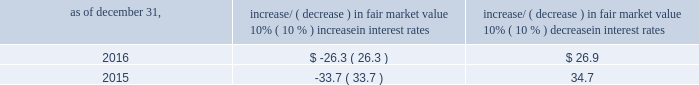Item 7a .
Quantitative and qualitative disclosures about market risk ( amounts in millions ) in the normal course of business , we are exposed to market risks related to interest rates , foreign currency rates and certain balance sheet items .
From time to time , we use derivative instruments , pursuant to established guidelines and policies , to manage some portion of these risks .
Derivative instruments utilized in our hedging activities are viewed as risk management tools and are not used for trading or speculative purposes .
Interest rates our exposure to market risk for changes in interest rates relates primarily to the fair market value and cash flows of our debt obligations .
The majority of our debt ( approximately 93% ( 93 % ) and 89% ( 89 % ) as of december 31 , 2016 and 2015 , respectively ) bears interest at fixed rates .
We do have debt with variable interest rates , but a 10% ( 10 % ) increase or decrease in interest rates would not be material to our interest expense or cash flows .
The fair market value of our debt is sensitive to changes in interest rates , and the impact of a 10% ( 10 % ) change in interest rates is summarized below .
Increase/ ( decrease ) in fair market value as of december 31 , 10% ( 10 % ) increase in interest rates 10% ( 10 % ) decrease in interest rates .
We have used interest rate swaps for risk management purposes to manage our exposure to changes in interest rates .
We do not have any interest rate swaps outstanding as of december 31 , 2016 .
We had $ 1100.6 of cash , cash equivalents and marketable securities as of december 31 , 2016 that we generally invest in conservative , short-term bank deposits or securities .
The interest income generated from these investments is subject to both domestic and foreign interest rate movements .
During 2016 and 2015 , we had interest income of $ 20.1 and $ 22.8 , respectively .
Based on our 2016 results , a 100 basis-point increase or decrease in interest rates would affect our interest income by approximately $ 11.0 , assuming that all cash , cash equivalents and marketable securities are impacted in the same manner and balances remain constant from year-end 2016 levels .
Foreign currency rates we are subject to translation and transaction risks related to changes in foreign currency exchange rates .
Since we report revenues and expenses in u.s .
Dollars , changes in exchange rates may either positively or negatively affect our consolidated revenues and expenses ( as expressed in u.s .
Dollars ) from foreign operations .
The foreign currencies that most impacted our results during 2016 included the british pound sterling and , to a lesser extent , the argentine peso , brazilian real and japanese yen .
Based on 2016 exchange rates and operating results , if the u.s .
Dollar were to strengthen or weaken by 10% ( 10 % ) , we currently estimate operating income would decrease or increase approximately 4% ( 4 % ) , assuming that all currencies are impacted in the same manner and our international revenue and expenses remain constant at 2016 levels .
The functional currency of our foreign operations is generally their respective local currency .
Assets and liabilities are translated at the exchange rates in effect at the balance sheet date , and revenues and expenses are translated at the average exchange rates during the period presented .
The resulting translation adjustments are recorded as a component of accumulated other comprehensive loss , net of tax , in the stockholders 2019 equity section of our consolidated balance sheets .
Our foreign subsidiaries generally collect revenues and pay expenses in their functional currency , mitigating transaction risk .
However , certain subsidiaries may enter into transactions in currencies other than their functional currency .
Assets and liabilities denominated in currencies other than the functional currency are susceptible to movements in foreign currency until final settlement .
Currency transaction gains or losses primarily arising from transactions in currencies other than the functional currency are included in office and general expenses .
We regularly review our foreign exchange exposures that may have a material impact on our business and from time to time use foreign currency forward exchange contracts or other derivative financial instruments to hedge the effects of potential adverse fluctuations in foreign currency exchange rates arising from these exposures .
We do not enter into foreign exchange contracts or other derivatives for speculative purposes. .
What is the statistical interval for 2017's interest income using 2016's interest income as a midpoint? 
Rationale: to find the statistical interval you need to subtract the change and also add the change to the year 2016 . this will give you a range of the next year to come .
Computations: (20.1 - 11.0)
Answer: 9.1. 